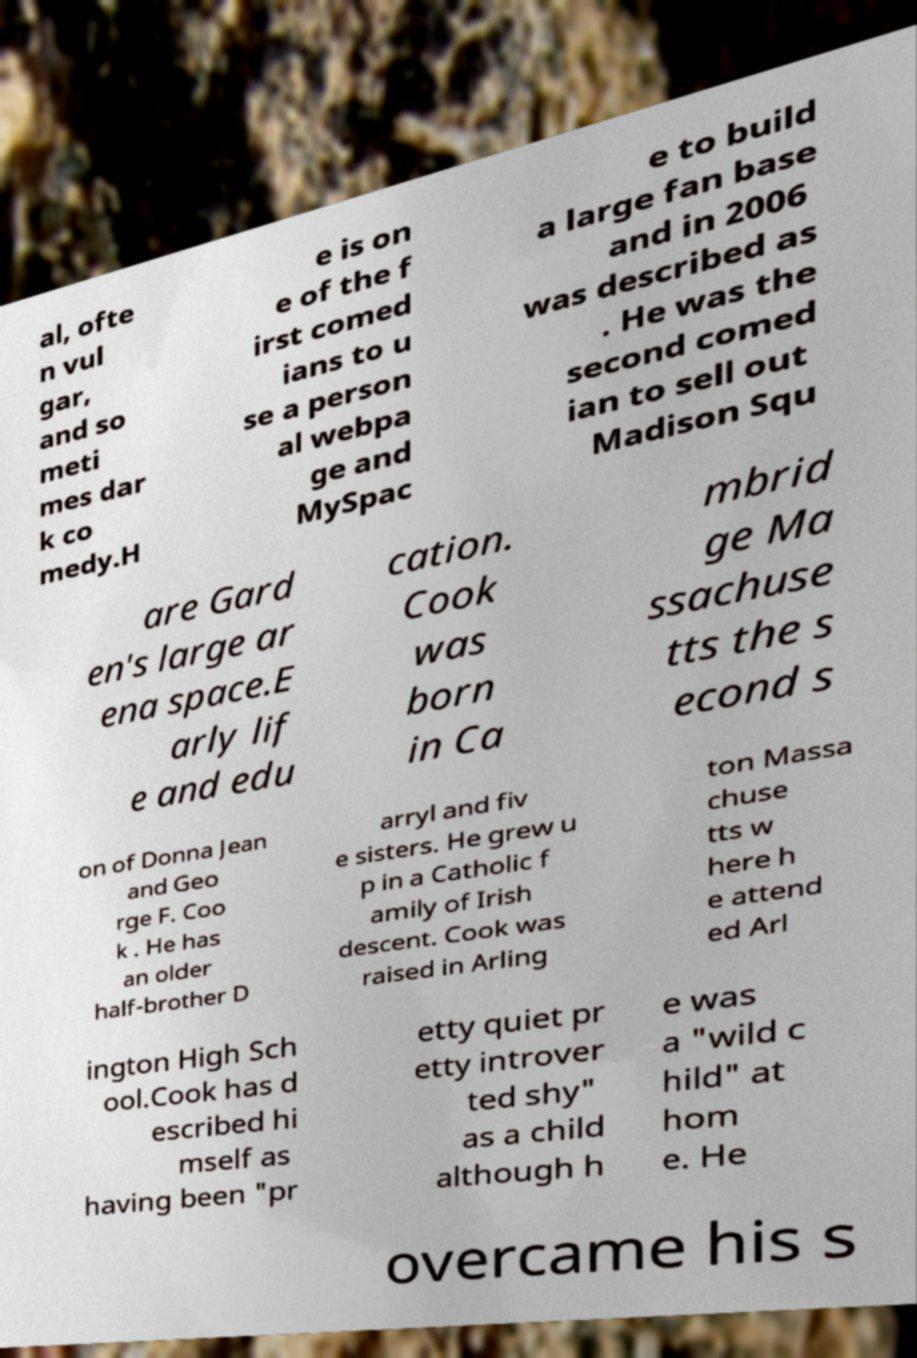Can you accurately transcribe the text from the provided image for me? al, ofte n vul gar, and so meti mes dar k co medy.H e is on e of the f irst comed ians to u se a person al webpa ge and MySpac e to build a large fan base and in 2006 was described as . He was the second comed ian to sell out Madison Squ are Gard en's large ar ena space.E arly lif e and edu cation. Cook was born in Ca mbrid ge Ma ssachuse tts the s econd s on of Donna Jean and Geo rge F. Coo k . He has an older half-brother D arryl and fiv e sisters. He grew u p in a Catholic f amily of Irish descent. Cook was raised in Arling ton Massa chuse tts w here h e attend ed Arl ington High Sch ool.Cook has d escribed hi mself as having been "pr etty quiet pr etty introver ted shy" as a child although h e was a "wild c hild" at hom e. He overcame his s 